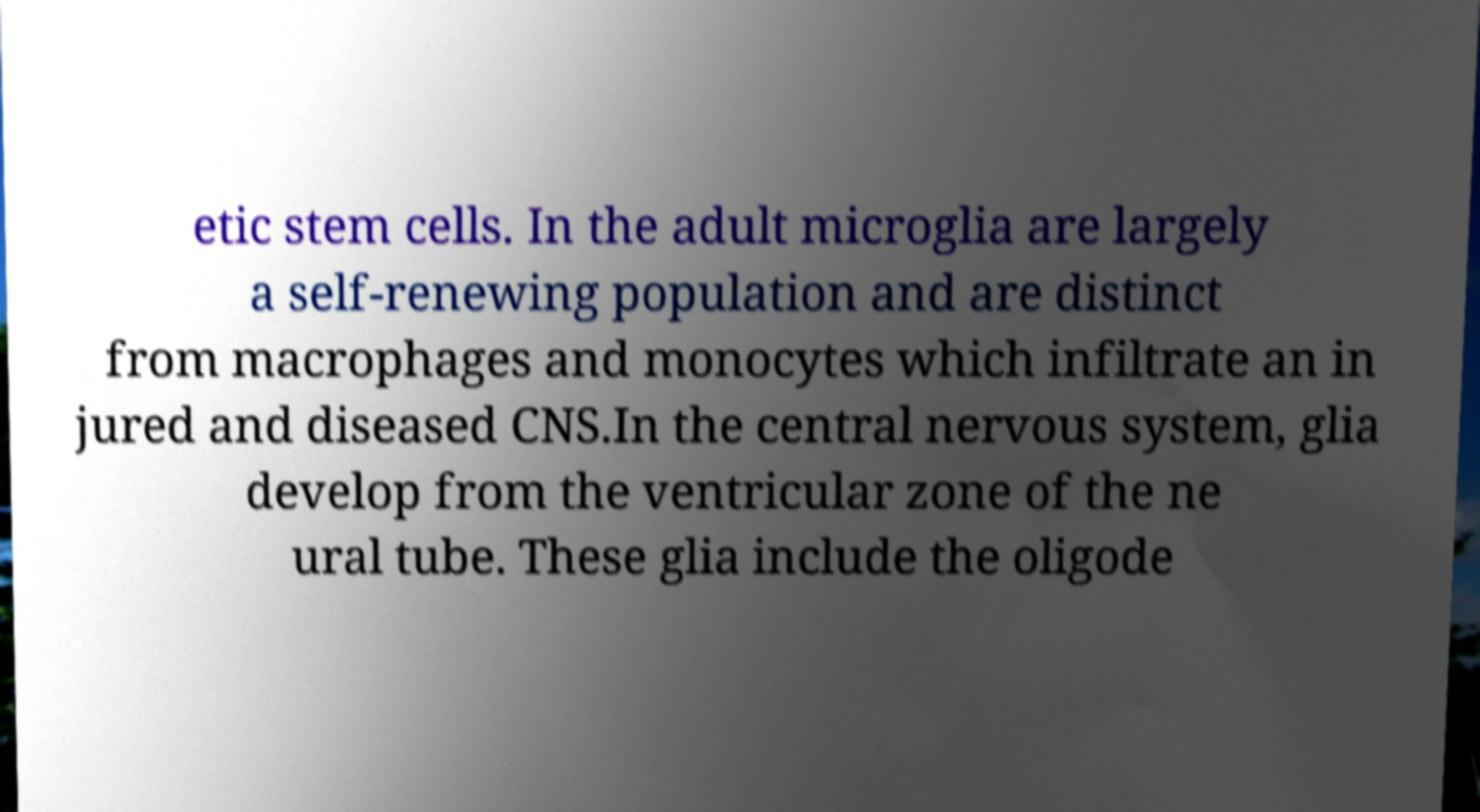There's text embedded in this image that I need extracted. Can you transcribe it verbatim? etic stem cells. In the adult microglia are largely a self-renewing population and are distinct from macrophages and monocytes which infiltrate an in jured and diseased CNS.In the central nervous system, glia develop from the ventricular zone of the ne ural tube. These glia include the oligode 